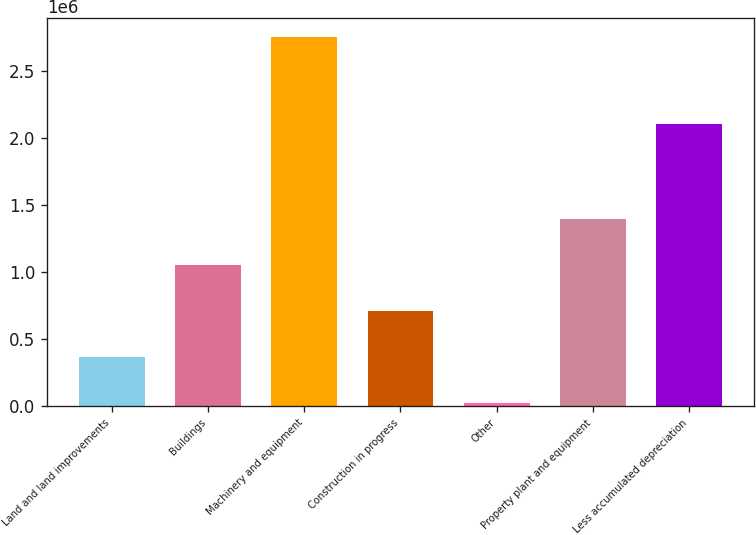<chart> <loc_0><loc_0><loc_500><loc_500><bar_chart><fcel>Land and land improvements<fcel>Buildings<fcel>Machinery and equipment<fcel>Construction in progress<fcel>Other<fcel>Property plant and equipment<fcel>Less accumulated depreciation<nl><fcel>366303<fcel>1.04924e+06<fcel>2.75326e+06<fcel>707771<fcel>24834<fcel>1.39071e+06<fcel>2.10154e+06<nl></chart> 